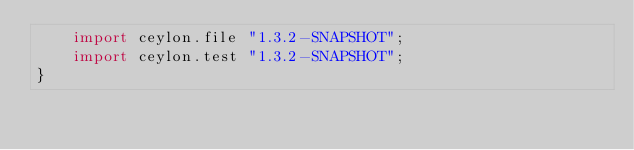Convert code to text. <code><loc_0><loc_0><loc_500><loc_500><_Ceylon_>    import ceylon.file "1.3.2-SNAPSHOT";
    import ceylon.test "1.3.2-SNAPSHOT";
}
</code> 